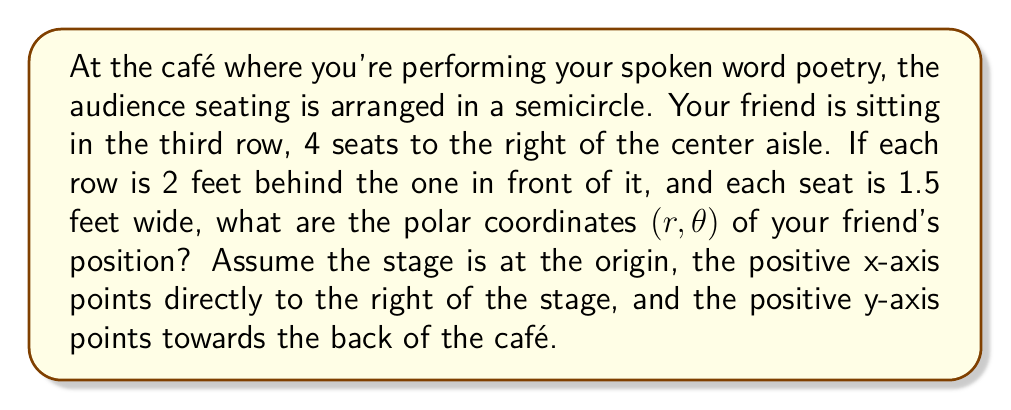Help me with this question. Let's approach this step-by-step:

1) First, we need to find the Cartesian coordinates $(x, y)$ of your friend's position.

   - For the x-coordinate: 
     Your friend is 4 seats to the right, and each seat is 1.5 feet wide.
     $x = 4 \times 1.5 = 6$ feet

   - For the y-coordinate:
     Your friend is in the third row, and each row is 2 feet behind the previous one.
     $y = 3 \times 2 = 6$ feet

   So, the Cartesian coordinates are $(6, 6)$.

2) To convert from Cartesian $(x, y)$ to polar $(r, \theta)$ coordinates, we use these formulas:

   $r = \sqrt{x^2 + y^2}$
   $\theta = \tan^{-1}(\frac{y}{x})$

3) Let's calculate $r$:
   
   $r = \sqrt{6^2 + 6^2} = \sqrt{72} = 6\sqrt{2}$ feet

4) Now let's calculate $\theta$:
   
   $\theta = \tan^{-1}(\frac{6}{6}) = \tan^{-1}(1) = \frac{\pi}{4}$ radians

5) Convert $\frac{\pi}{4}$ radians to degrees:
   
   $\frac{\pi}{4}$ radians $= 45°$

Therefore, the polar coordinates of your friend's position are $(6\sqrt{2}, 45°)$.
Answer: $(6\sqrt{2}, 45°)$ 